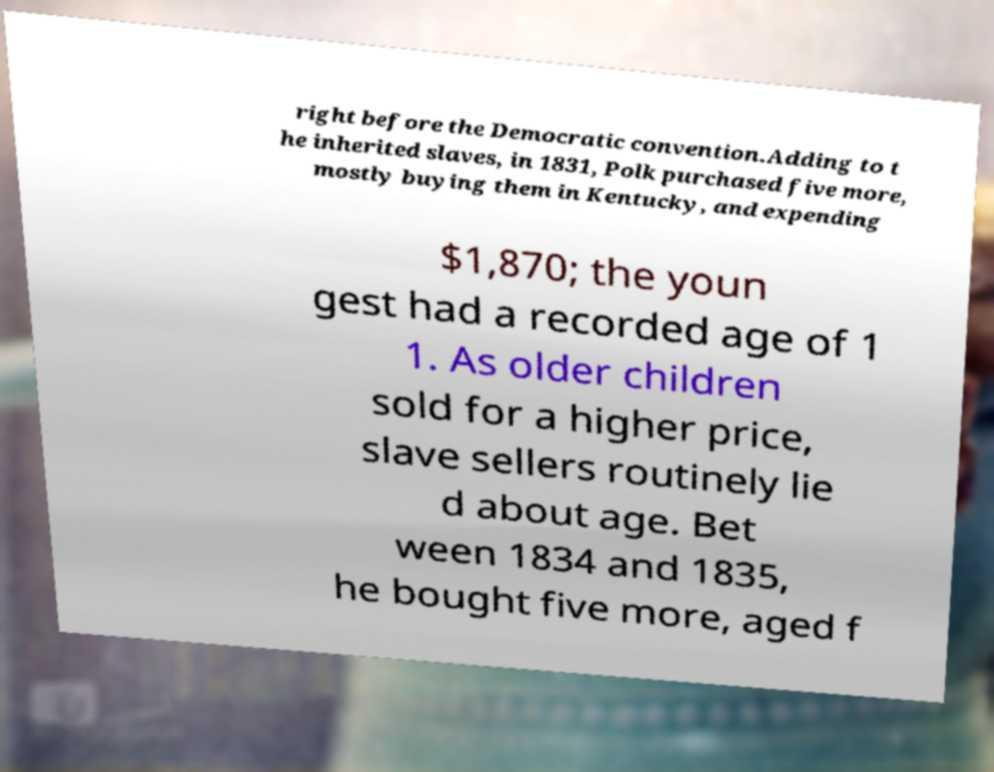Please read and relay the text visible in this image. What does it say? right before the Democratic convention.Adding to t he inherited slaves, in 1831, Polk purchased five more, mostly buying them in Kentucky, and expending $1,870; the youn gest had a recorded age of 1 1. As older children sold for a higher price, slave sellers routinely lie d about age. Bet ween 1834 and 1835, he bought five more, aged f 